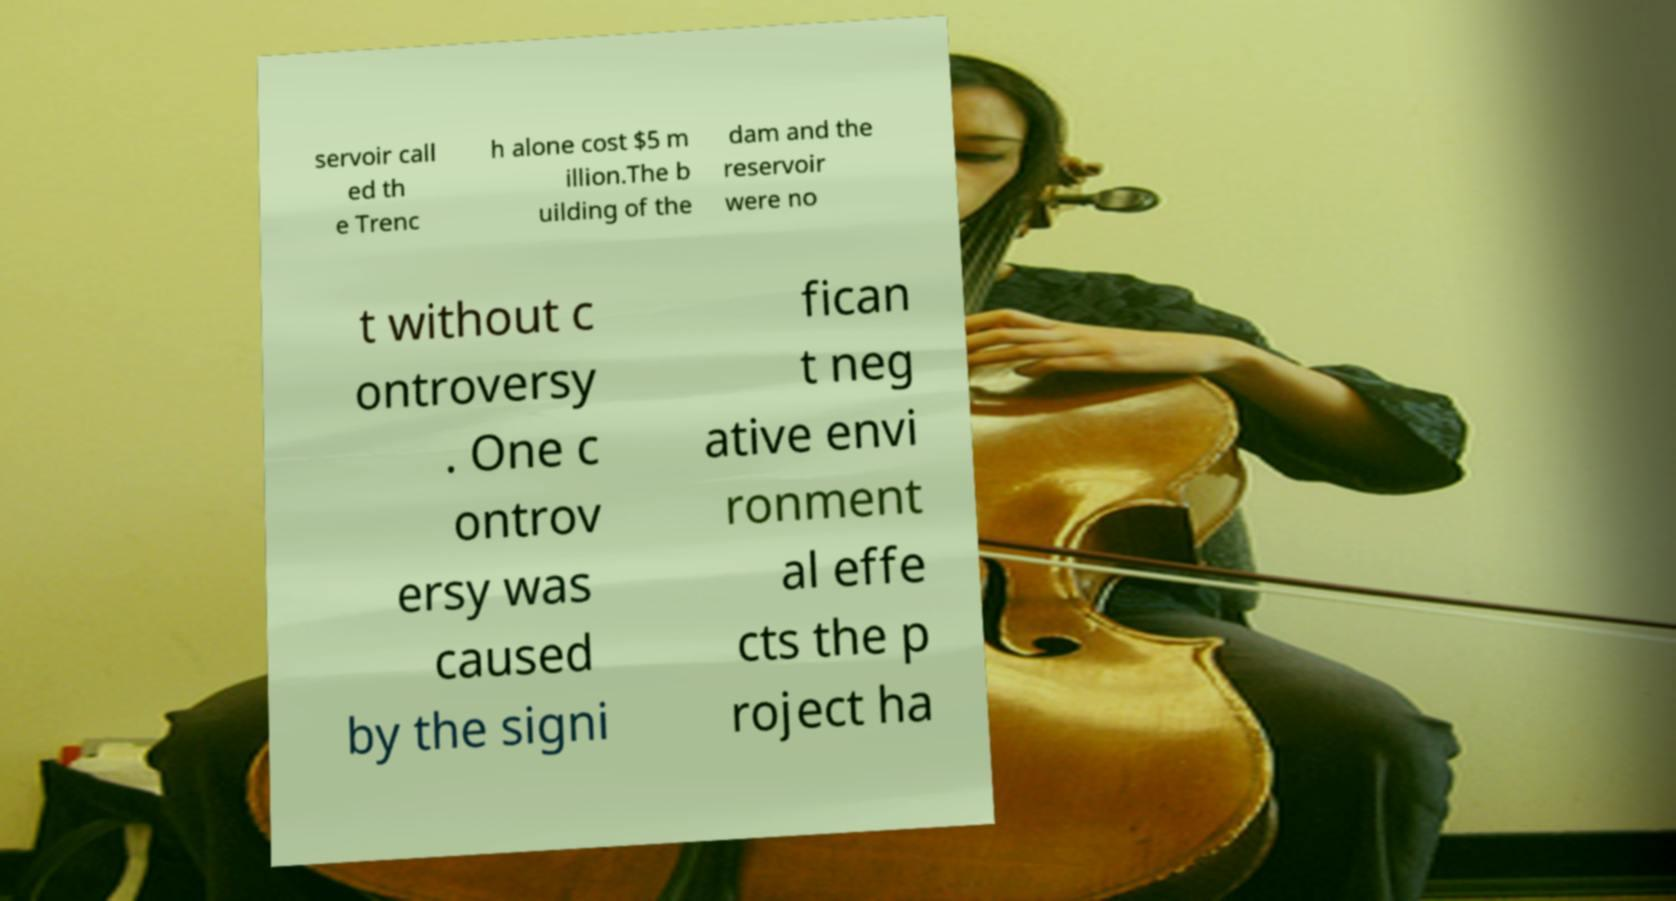What messages or text are displayed in this image? I need them in a readable, typed format. servoir call ed th e Trenc h alone cost $5 m illion.The b uilding of the dam and the reservoir were no t without c ontroversy . One c ontrov ersy was caused by the signi fican t neg ative envi ronment al effe cts the p roject ha 